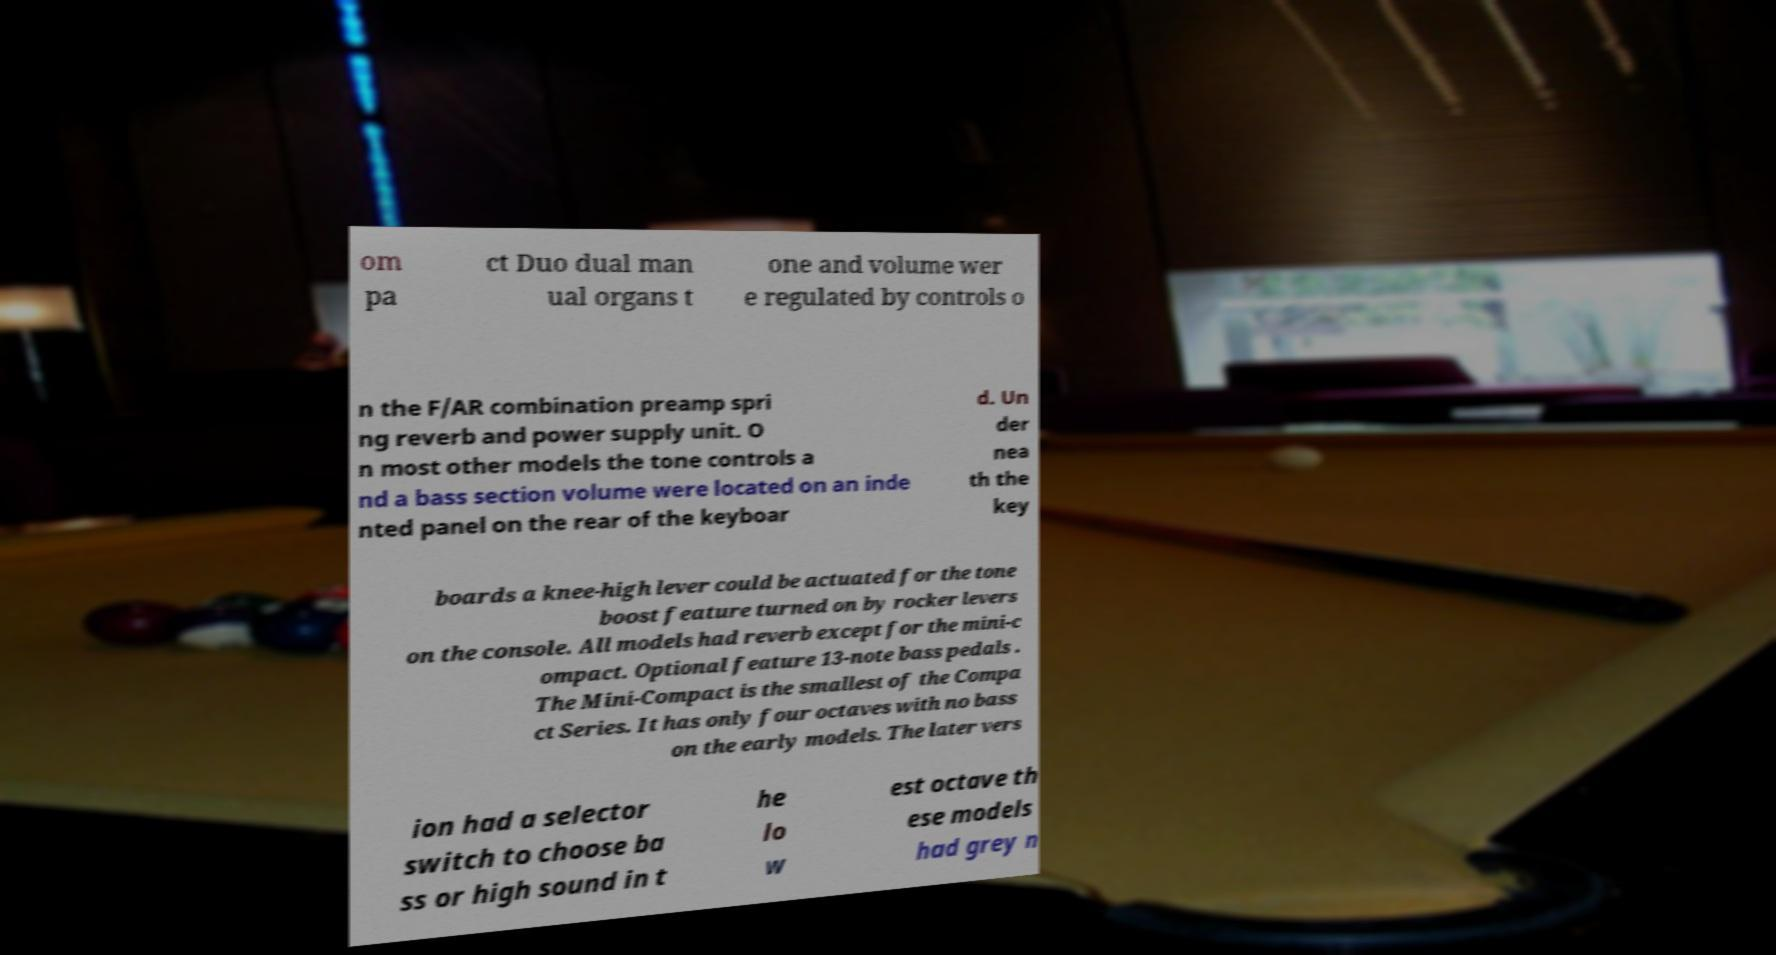Please identify and transcribe the text found in this image. om pa ct Duo dual man ual organs t one and volume wer e regulated by controls o n the F/AR combination preamp spri ng reverb and power supply unit. O n most other models the tone controls a nd a bass section volume were located on an inde nted panel on the rear of the keyboar d. Un der nea th the key boards a knee-high lever could be actuated for the tone boost feature turned on by rocker levers on the console. All models had reverb except for the mini-c ompact. Optional feature 13-note bass pedals . The Mini-Compact is the smallest of the Compa ct Series. It has only four octaves with no bass on the early models. The later vers ion had a selector switch to choose ba ss or high sound in t he lo w est octave th ese models had grey n 